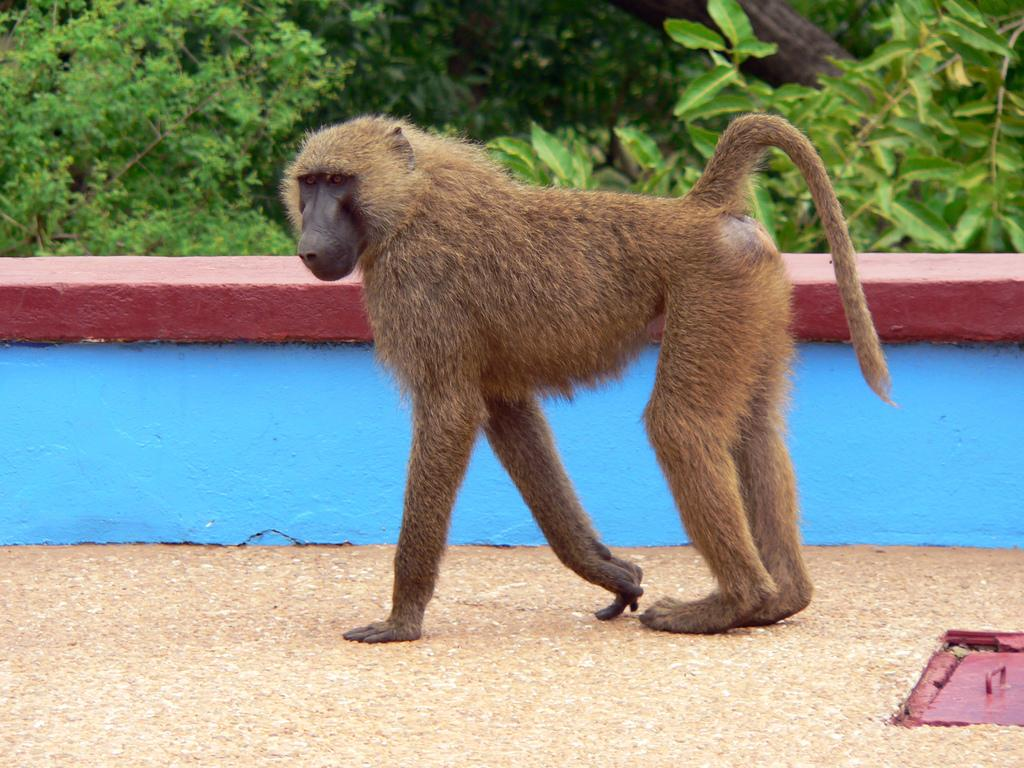What animal is present in the image? There is a monkey in the image. What is the monkey doing in the image? The monkey is walking on the ground and moving towards the left side. What can be seen in the background of the image? There is a wall and plants visible in the background of the image. What type of fowl can be seen sitting on the wall in the image? There is no fowl present in the image; it only features a monkey walking on the ground. What kind of marble is visible in the image? There is no marble present in the image. 